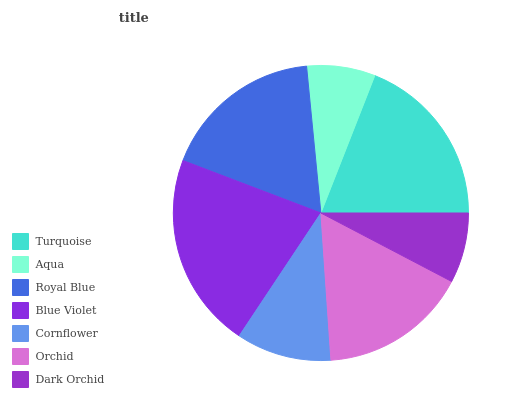Is Aqua the minimum?
Answer yes or no. Yes. Is Blue Violet the maximum?
Answer yes or no. Yes. Is Royal Blue the minimum?
Answer yes or no. No. Is Royal Blue the maximum?
Answer yes or no. No. Is Royal Blue greater than Aqua?
Answer yes or no. Yes. Is Aqua less than Royal Blue?
Answer yes or no. Yes. Is Aqua greater than Royal Blue?
Answer yes or no. No. Is Royal Blue less than Aqua?
Answer yes or no. No. Is Orchid the high median?
Answer yes or no. Yes. Is Orchid the low median?
Answer yes or no. Yes. Is Aqua the high median?
Answer yes or no. No. Is Royal Blue the low median?
Answer yes or no. No. 